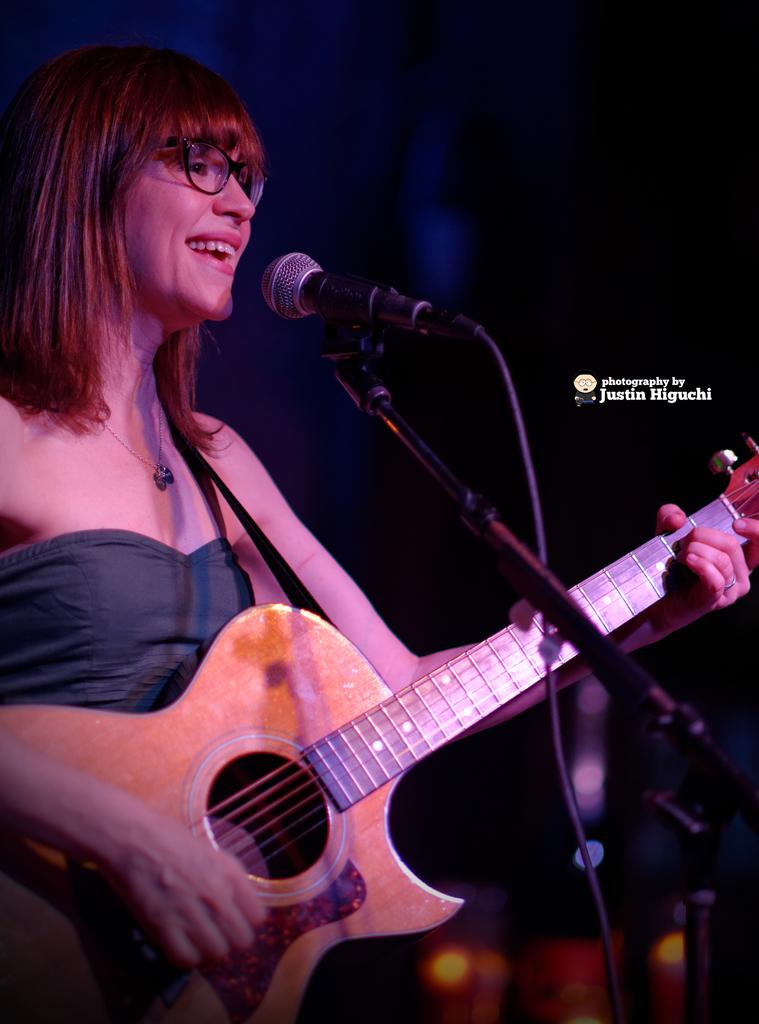What is the main subject of the image? The main subject of the image is a beautiful woman. What is the woman doing in the image? The woman is standing in front of a microphone and playing a guitar. What accessory is the woman wearing in the image? The woman is wearing spectacles. What type of machine can be seen in the background of the image? There is no machine visible in the background of the image. Can you tell me how many yaks are present in the image? There are no yaks present in the image. 